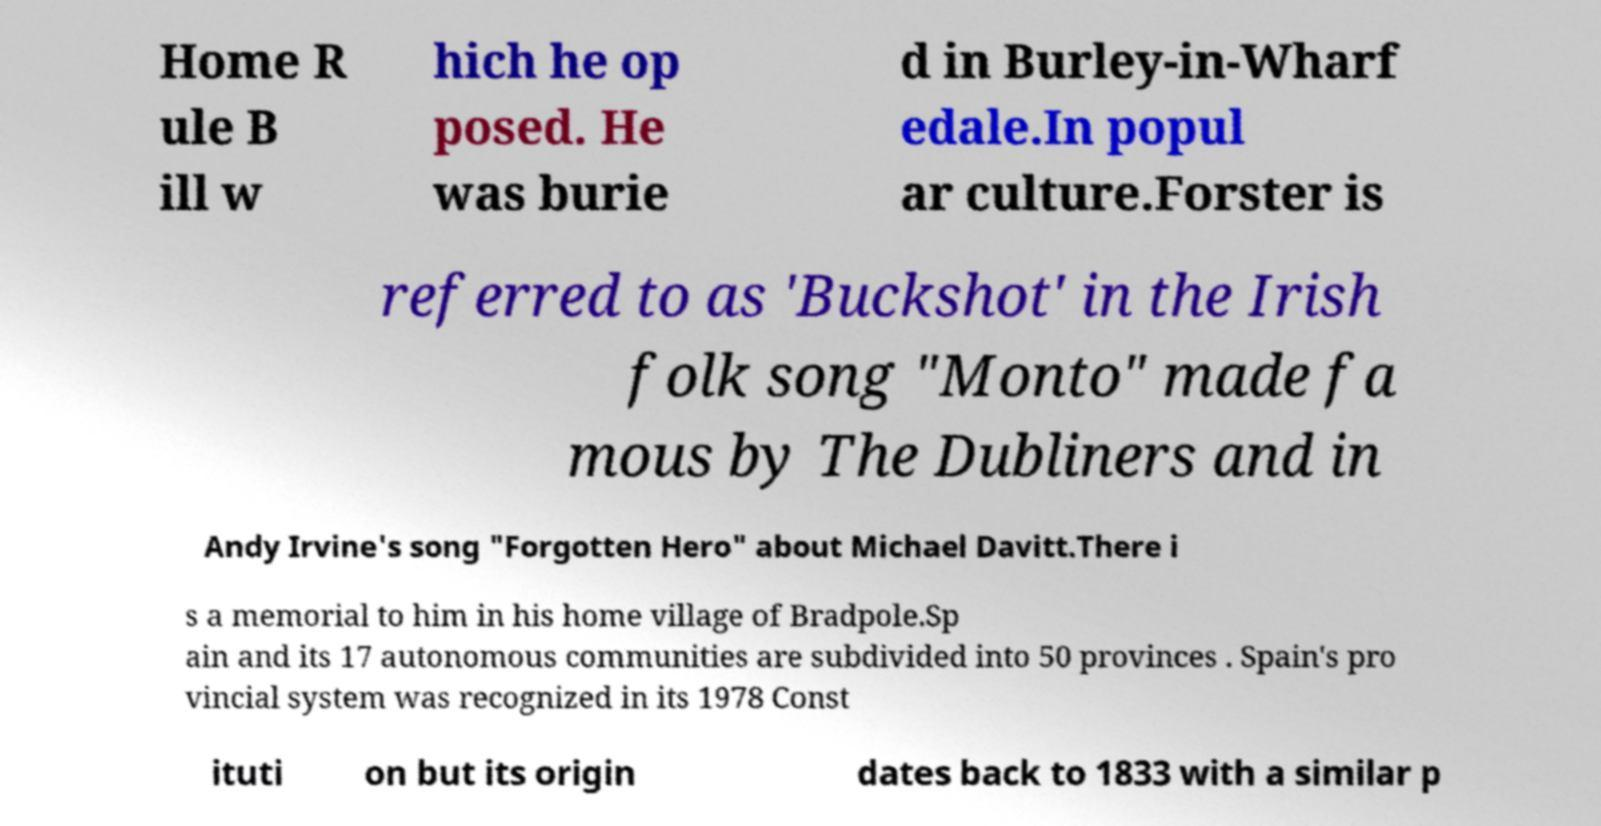For documentation purposes, I need the text within this image transcribed. Could you provide that? Home R ule B ill w hich he op posed. He was burie d in Burley-in-Wharf edale.In popul ar culture.Forster is referred to as 'Buckshot' in the Irish folk song "Monto" made fa mous by The Dubliners and in Andy Irvine's song "Forgotten Hero" about Michael Davitt.There i s a memorial to him in his home village of Bradpole.Sp ain and its 17 autonomous communities are subdivided into 50 provinces . Spain's pro vincial system was recognized in its 1978 Const ituti on but its origin dates back to 1833 with a similar p 